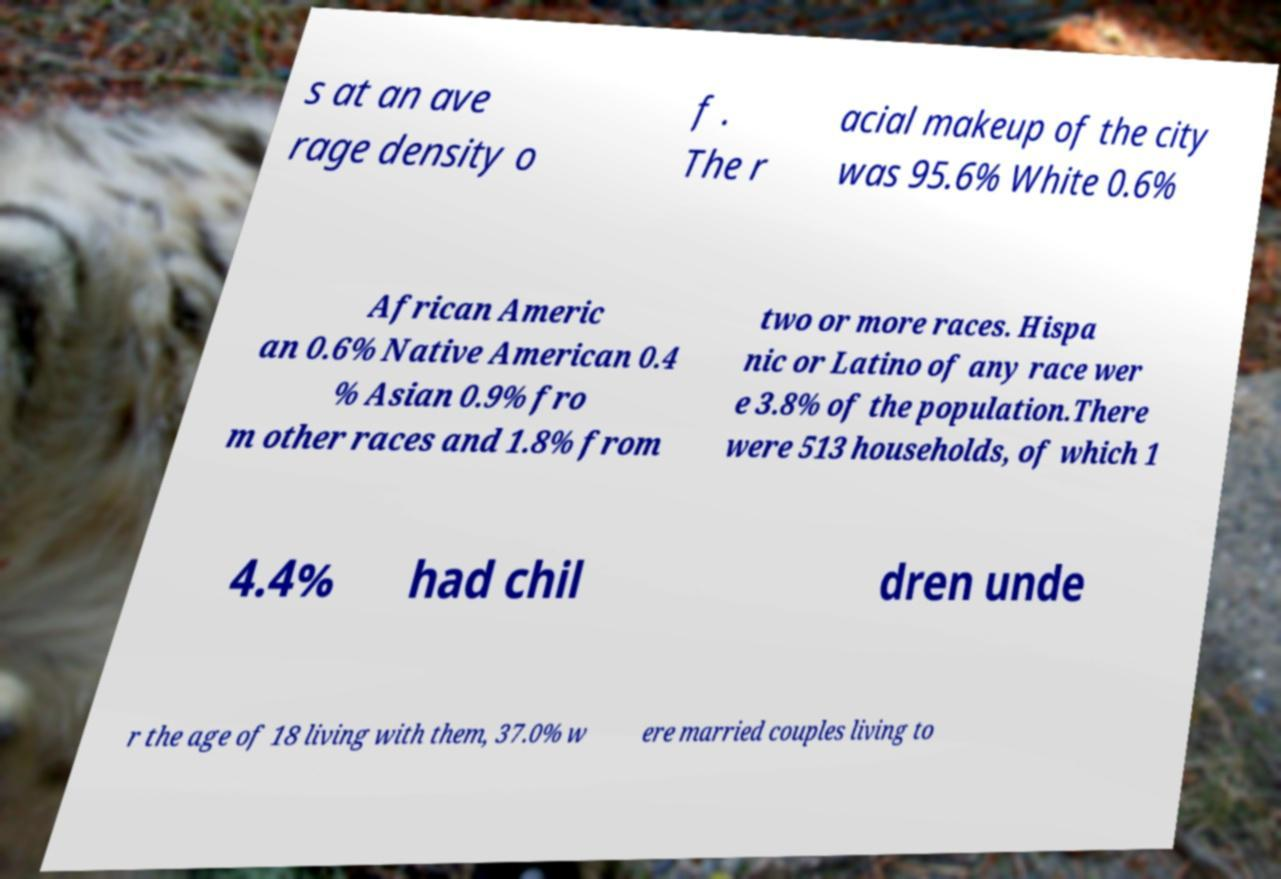Could you assist in decoding the text presented in this image and type it out clearly? s at an ave rage density o f . The r acial makeup of the city was 95.6% White 0.6% African Americ an 0.6% Native American 0.4 % Asian 0.9% fro m other races and 1.8% from two or more races. Hispa nic or Latino of any race wer e 3.8% of the population.There were 513 households, of which 1 4.4% had chil dren unde r the age of 18 living with them, 37.0% w ere married couples living to 